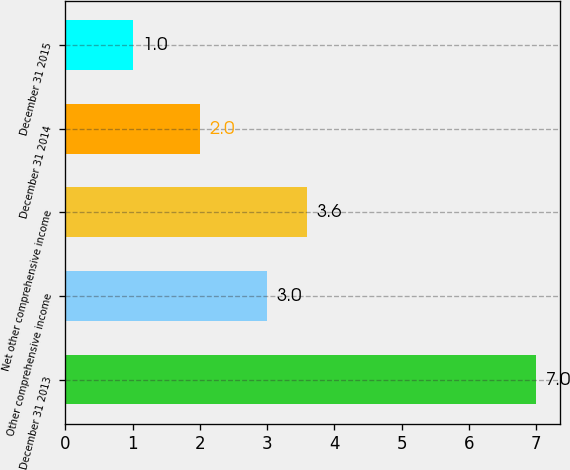Convert chart to OTSL. <chart><loc_0><loc_0><loc_500><loc_500><bar_chart><fcel>December 31 2013<fcel>Other comprehensive income<fcel>Net other comprehensive income<fcel>December 31 2014<fcel>December 31 2015<nl><fcel>7<fcel>3<fcel>3.6<fcel>2<fcel>1<nl></chart> 